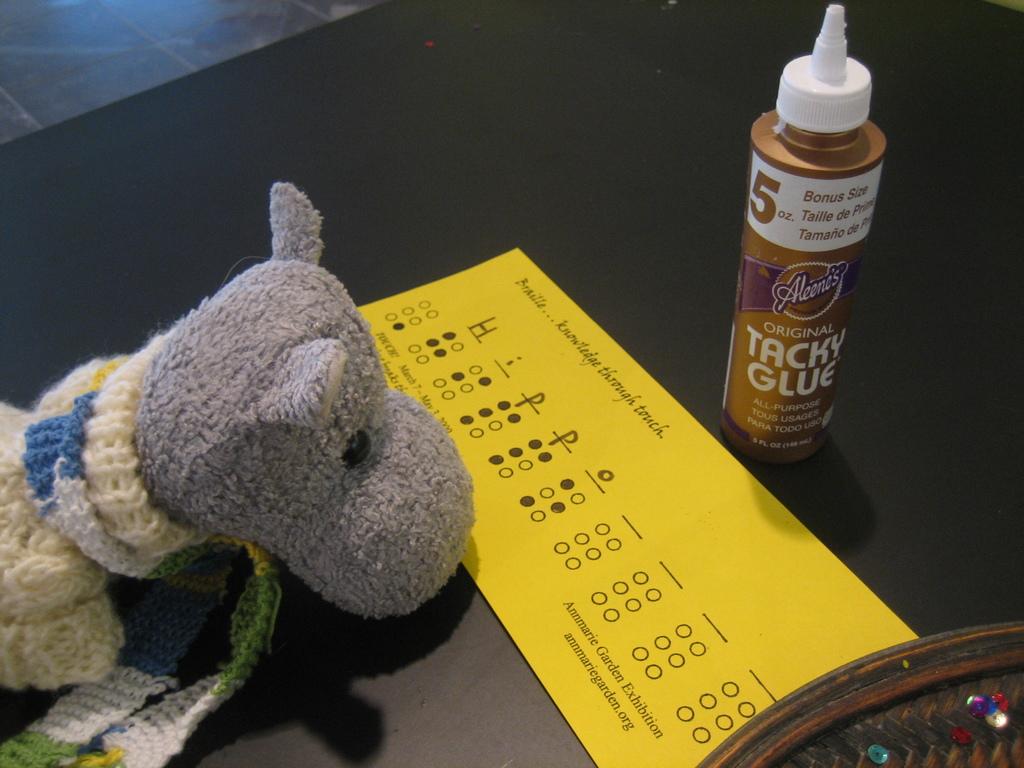What kind of glue is it?
Give a very brief answer. Tacky. What website is on the yellow card?
Your response must be concise. Annmariegarden.org. 